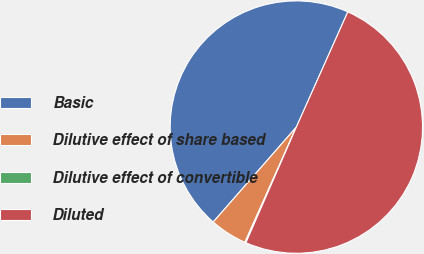Convert chart to OTSL. <chart><loc_0><loc_0><loc_500><loc_500><pie_chart><fcel>Basic<fcel>Dilutive effect of share based<fcel>Dilutive effect of convertible<fcel>Diluted<nl><fcel>45.24%<fcel>4.76%<fcel>0.14%<fcel>49.86%<nl></chart> 